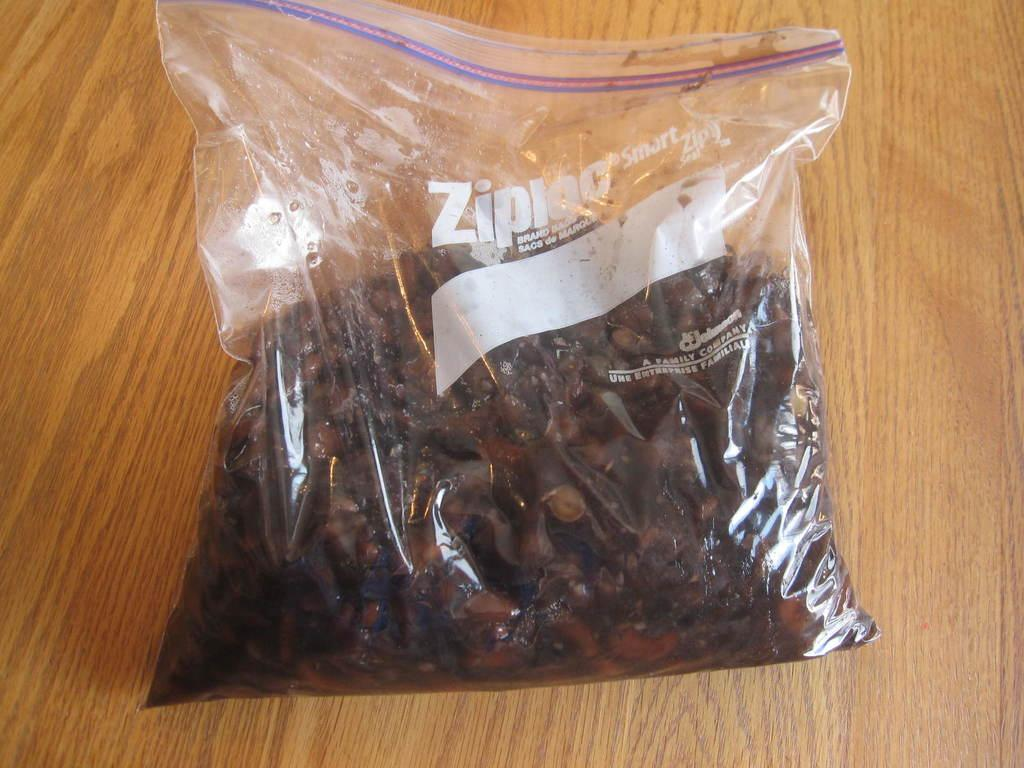What is the main object in the image? There is a plastic cover in the image. What is inside the plastic cover? The plastic cover contains food items. Where is the plastic cover located? The plastic cover is placed on a table. Can you see a ship in the image? No, there is no ship present in the image. How many times do you need to touch the plastic cover to see the food items inside? There is no need to touch the plastic cover to see the food items inside, as they are visible through the transparent material. 